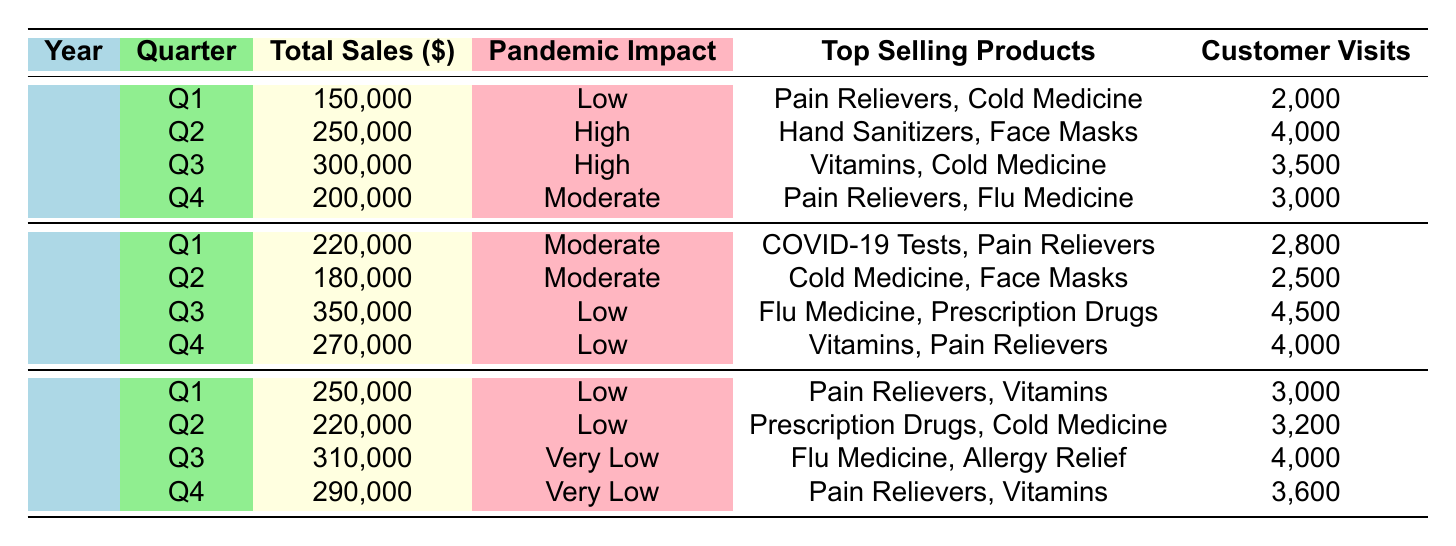What was the total sales value in Quarter 2 of 2021? The total sales value for Quarter 2 in 2021 is directly provided in the table as 180,000.
Answer: 180,000 How many customer visits were recorded in Quarter 3 of 2020? The table shows that there were 3,500 customer visits in Quarter 3 of 2020.
Answer: 3,500 Which quarter had the highest total sales in 2021? The table indicates that Quarter 3 of 2021 had the highest total sales, with a value of 350,000.
Answer: Quarter 3 What is the average total sales across all quarters in 2022? To find the average total sales for 2022, sum the values of all quarters: 250,000 + 220,000 + 310,000 + 290,000 = 1,070,000. Since there are 4 quarters, divide by 4: 1,070,000 / 4 = 267,500.
Answer: 267,500 During which quarter in 2020 was the pandemic impact considered high? The table shows that the pandemic impact was considered high in both Quarter 2 and Quarter 3 of 2020.
Answer: Quarter 2 and Quarter 3 Is it true that Pain Relievers were a top-selling product in every quarter of 2021? A review of the table confirms that Pain Relievers were a top-selling product in Quarter 1 and Quarter 4, but not in Quarter 2 or Quarter 3. Therefore, the statement is false.
Answer: No What is the difference in total sales between Q1 and Q4 of 2022? The total sales for Q1 of 2022 are 250,000, and for Q4 they are 290,000. The difference is calculated as 290,000 - 250,000 = 40,000.
Answer: 40,000 Was there any quarter in 2022 where the pandemic impact was classified as high? Referring to the table, all quarters in 2022 have a pandemic impact classified as Low or Very Low. Thus, there were no quarters with high impact in 2022.
Answer: No Which top-selling product appeared in both Quarter 2 of 2021 and Quarter 1 of 2022? The table indicates that Cold Medicine was a top-selling product in Quarter 2 of 2021 and also in Quarter 2 of 2022, confirming its presence in both quarters.
Answer: Cold Medicine 